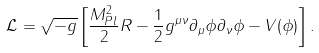Convert formula to latex. <formula><loc_0><loc_0><loc_500><loc_500>\mathcal { L } = \sqrt { - g } \left [ \frac { M _ { P l } ^ { 2 } } { 2 } R - \frac { 1 } { 2 } g ^ { \mu \nu } \partial _ { \mu } \phi \partial _ { \nu } \phi - V ( \phi ) \right ] .</formula> 